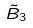<formula> <loc_0><loc_0><loc_500><loc_500>\tilde { B } _ { 3 }</formula> 